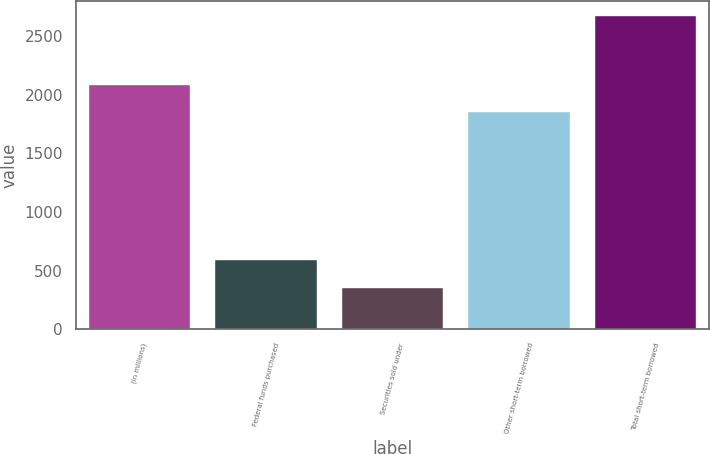Convert chart to OTSL. <chart><loc_0><loc_0><loc_500><loc_500><bar_chart><fcel>(in millions)<fcel>Federal funds purchased<fcel>Securities sold under<fcel>Other short-term borrowed<fcel>Total short-term borrowed<nl><fcel>2087.6<fcel>586.6<fcel>355<fcel>1856<fcel>2671<nl></chart> 